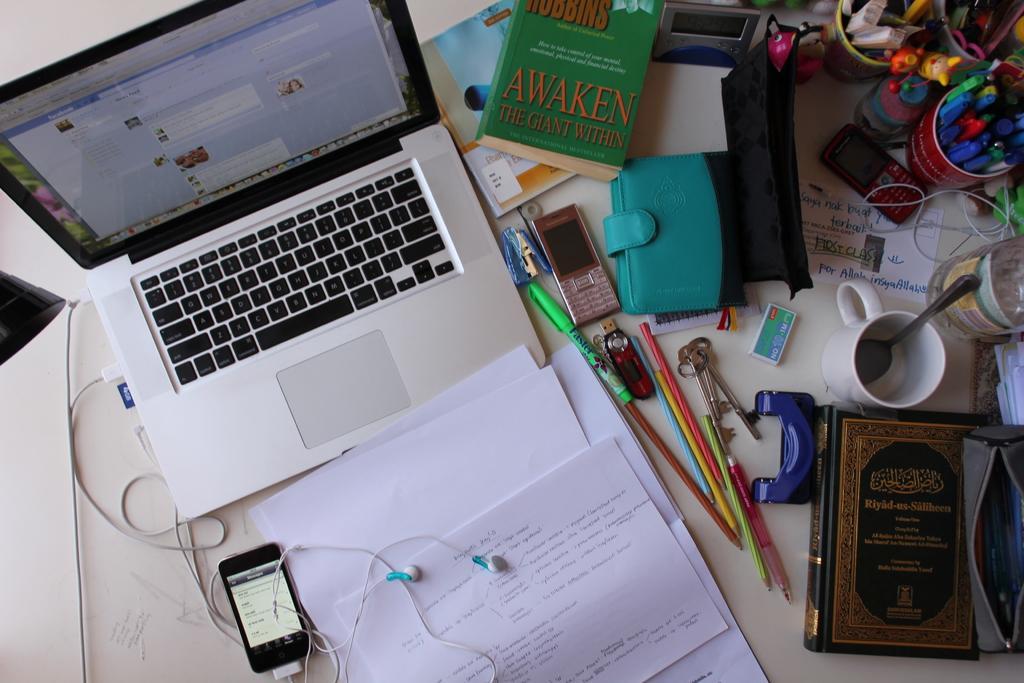Describe this image in one or two sentences. This picture shows a mobile with earphones and we see a laptop and few papers, teacup and couple of pen stands and a book and two wallets and a mobile on the table 